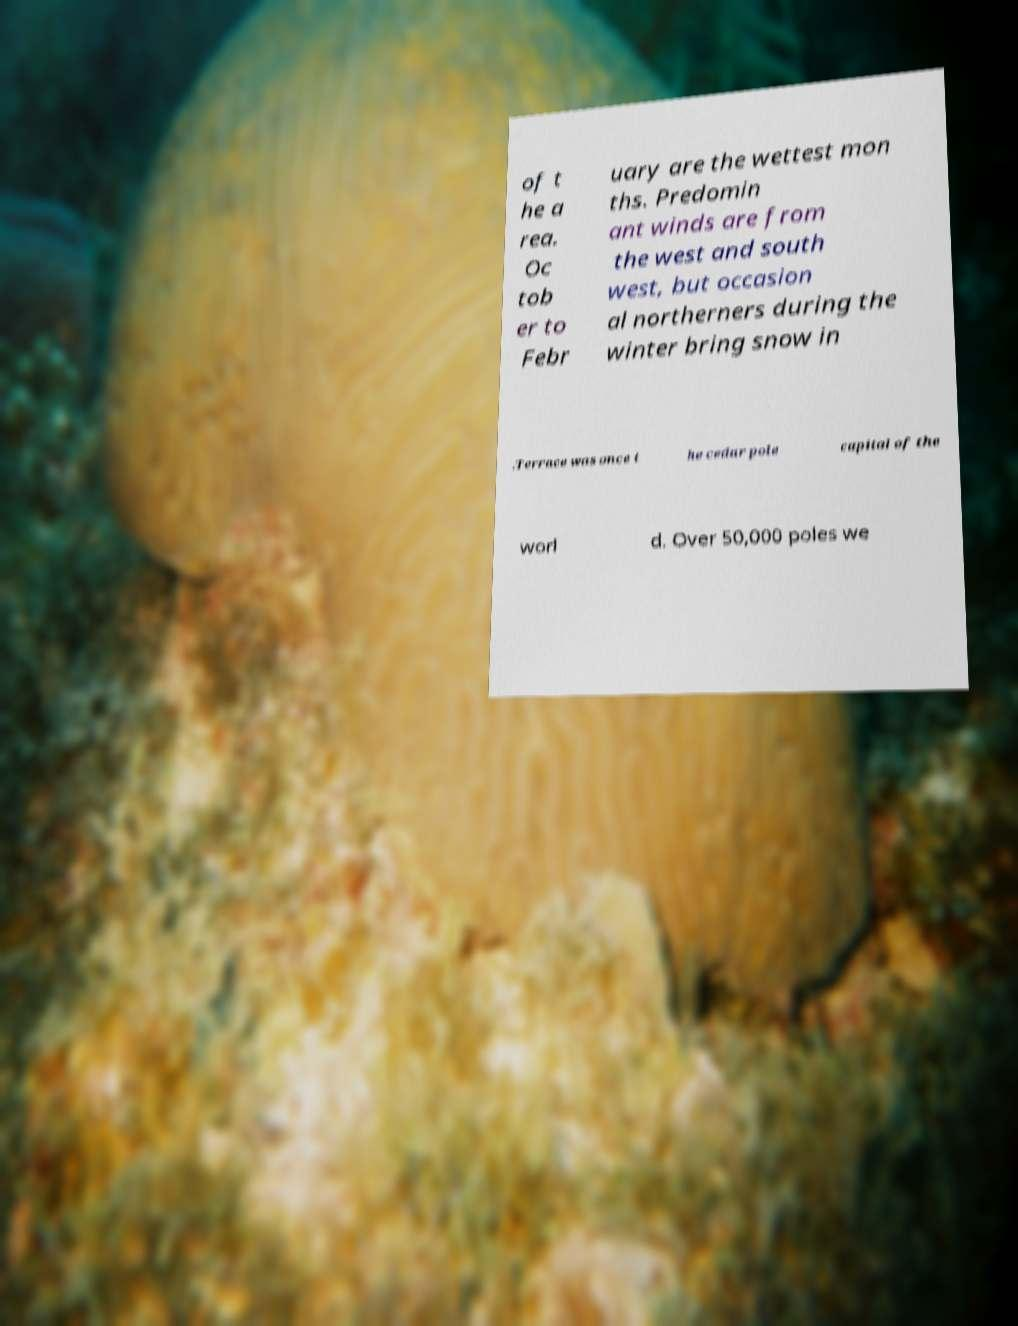What messages or text are displayed in this image? I need them in a readable, typed format. of t he a rea. Oc tob er to Febr uary are the wettest mon ths. Predomin ant winds are from the west and south west, but occasion al northerners during the winter bring snow in .Terrace was once t he cedar pole capital of the worl d. Over 50,000 poles we 